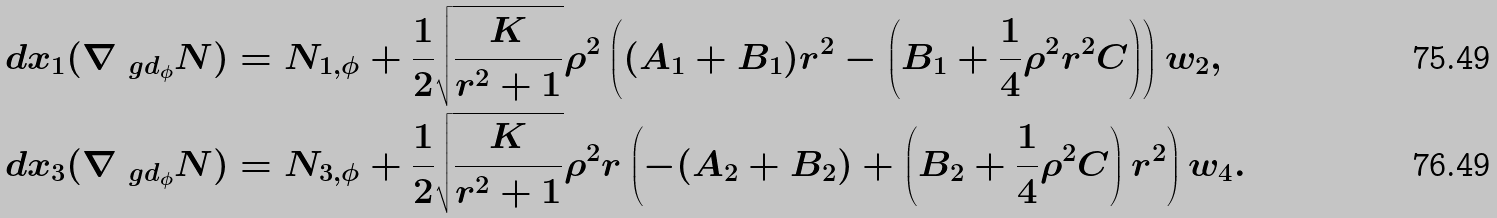<formula> <loc_0><loc_0><loc_500><loc_500>d x _ { 1 } ( \nabla _ { \ g d _ { \phi } } N ) & = N _ { 1 , \phi } + \frac { 1 } { 2 } \sqrt { \frac { K } { r ^ { 2 } + 1 } } \rho ^ { 2 } \left ( ( A _ { 1 } + B _ { 1 } ) r ^ { 2 } - \left ( B _ { 1 } + \frac { 1 } 4 \rho ^ { 2 } r ^ { 2 } C \right ) \right ) w _ { 2 } , \\ d x _ { 3 } ( \nabla _ { \ g d _ { \phi } } N ) & = N _ { 3 , \phi } + \frac { 1 } { 2 } \sqrt { \frac { K } { r ^ { 2 } + 1 } } \rho ^ { 2 } r \left ( - ( A _ { 2 } + B _ { 2 } ) + \left ( B _ { 2 } + \frac { 1 } 4 \rho ^ { 2 } C \right ) r ^ { 2 } \right ) w _ { 4 } .</formula> 